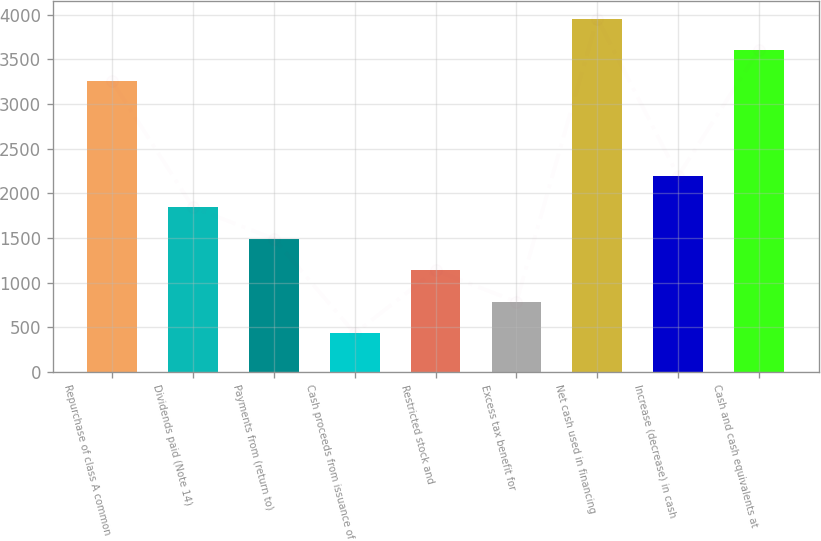Convert chart. <chart><loc_0><loc_0><loc_500><loc_500><bar_chart><fcel>Repurchase of class A common<fcel>Dividends paid (Note 14)<fcel>Payments from (return to)<fcel>Cash proceeds from issuance of<fcel>Restricted stock and<fcel>Excess tax benefit for<fcel>Net cash used in financing<fcel>Increase (decrease) in cash<fcel>Cash and cash equivalents at<nl><fcel>3250.8<fcel>1842<fcel>1489.8<fcel>433.2<fcel>1137.6<fcel>785.4<fcel>3955.2<fcel>2194.2<fcel>3603<nl></chart> 